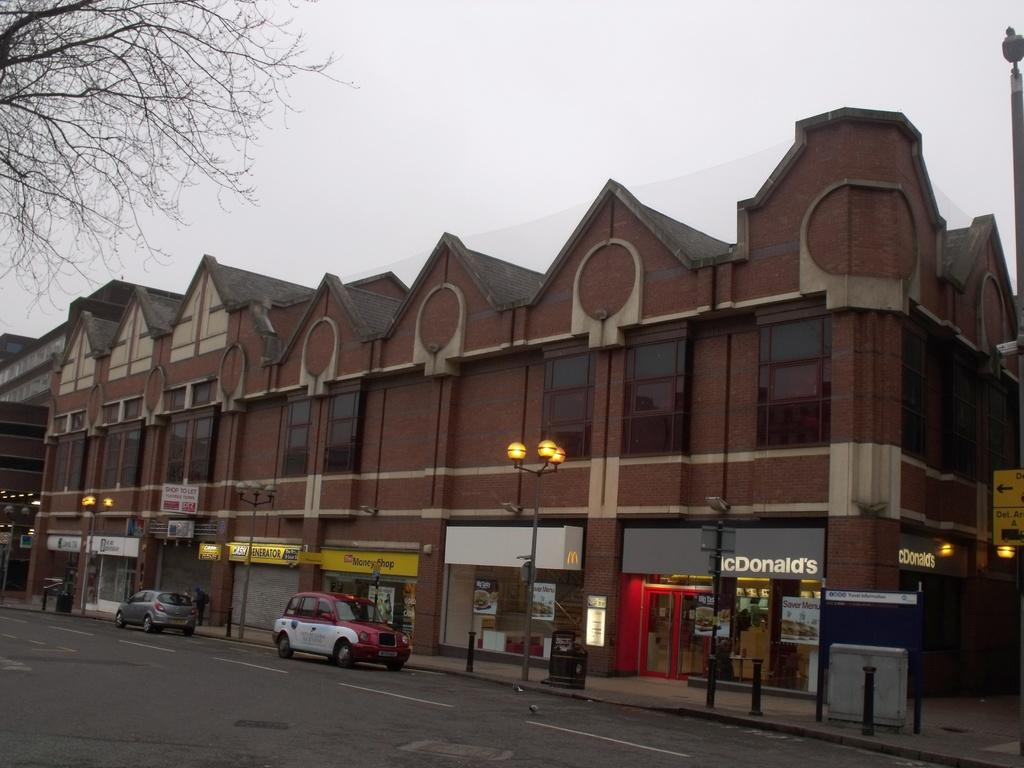<image>
Render a clear and concise summary of the photo. A McDonalds fast food restaurant can be seen in this row of shops. 